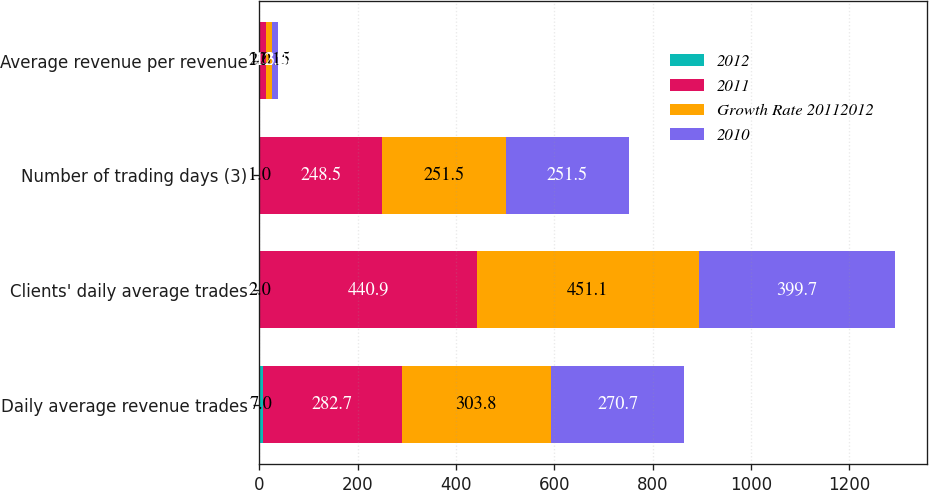Convert chart. <chart><loc_0><loc_0><loc_500><loc_500><stacked_bar_chart><ecel><fcel>Daily average revenue trades<fcel>Clients' daily average trades<fcel>Number of trading days (3)<fcel>Average revenue per revenue<nl><fcel>2012<fcel>7<fcel>2<fcel>1<fcel>2<nl><fcel>2011<fcel>282.7<fcel>440.9<fcel>248.5<fcel>12.35<nl><fcel>Growth Rate 20112012<fcel>303.8<fcel>451.1<fcel>251.5<fcel>12.15<nl><fcel>2010<fcel>270.7<fcel>399.7<fcel>251.5<fcel>12.28<nl></chart> 